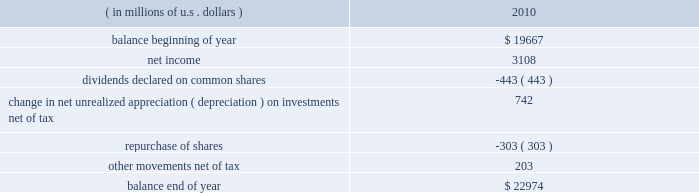The table reports the significant movements in our shareholders 2019 equity for the year ended december 31 , 2010. .
Total shareholders 2019 equity increased $ 3.3 billion in 2010 , primarily due to net income of $ 3.1 billion and the change in net unrealized appreciation on investments of $ 742 million .
Short-term debt at december 31 , 2010 , in connection with the financing of the rain and hail acquisition , short-term debt includes reverse repurchase agreements totaling $ 1 billion .
In addition , $ 300 million in borrowings against ace 2019s revolving credit facility were outstanding at december 31 , 2010 .
At december 31 , 2009 , short-term debt consisted of a five-year term loan which we repaid in december 2010 .
Long-term debt our total long-term debt increased by $ 200 million during the year to $ 3.4 billion and is described in detail in note 9 to the consolidated financial statements , under item 8 .
In november 2010 , ace ina issued $ 700 million of 2.6 percent senior notes due november 2015 .
These senior unsecured notes are guaranteed on a senior basis by the company and they rank equally with all of the company 2019s other senior obligations .
In april 2008 , as part of the financing of the combined insurance acquisition , ace ina entered into a $ 450 million float- ing interest rate syndicated term loan agreement due april 2013 .
Simultaneously , the company entered into a swap transaction that had the economic effect of fixing the interest rate for the term of the loan .
In december 2010 , ace repaid this loan and exited the swap .
In december 2008 , ace ina entered into a $ 66 million dual tranche floating interest rate term loan agreement .
The first tranche , a $ 50 million three-year term loan due december 2011 , had a floating interest rate .
Simultaneously , the company entered into a swap transaction that had the economic effect of fixing the interest rate for the term of the loan .
In december 2010 , ace repaid this loan and exited the swap .
The second tranche , a $ 16 million nine-month term loan , was due and repaid in september 2009 .
Trust preferred securities the securities outstanding consist of $ 300 million of trust preferred securities due 2030 , issued by a special purpose entity ( a trust ) that is wholly owned by us .
The sole assets of the special purpose entity are debt instruments issued by one or more of our subsidiaries .
The special purpose entity looks to payments on the debt instruments to make payments on the preferred securities .
We have guaranteed the payments on these debt instruments .
The trustees of the trust include one or more of our officers and at least one independent trustee , such as a trust company .
Our officers serving as trustees of the trust do not receive any compensation or other remuneration for their services in such capacity .
The full $ 309 million of outstanding trust preferred securities ( calculated as $ 300 million as discussed above plus our equity share of the trust ) is shown on our con- solidated balance sheet as a liability .
Additional information with respect to the trust preferred securities is contained in note 9 d ) to the consolidated financial statements , under item 8 .
Common shares our common shares had a par value of chf 30.57 each at december 31 , 2010 .
At the annual general meeting held in may 2010 , the company 2019s shareholders approved a par value reduction in an aggregate swiss franc amount , pursuant to a formula , equal to $ 1.32 per share , which we refer to as the base annual divi- dend .
The base annual dividend is payable in four installments , provided that each of the swiss franc installments will be .
What is the net change in shareholders 2019 equity in 2010 ( in millions ) ? 
Computations: (22974 - 19667)
Answer: 3307.0. The table reports the significant movements in our shareholders 2019 equity for the year ended december 31 , 2010. .
Total shareholders 2019 equity increased $ 3.3 billion in 2010 , primarily due to net income of $ 3.1 billion and the change in net unrealized appreciation on investments of $ 742 million .
Short-term debt at december 31 , 2010 , in connection with the financing of the rain and hail acquisition , short-term debt includes reverse repurchase agreements totaling $ 1 billion .
In addition , $ 300 million in borrowings against ace 2019s revolving credit facility were outstanding at december 31 , 2010 .
At december 31 , 2009 , short-term debt consisted of a five-year term loan which we repaid in december 2010 .
Long-term debt our total long-term debt increased by $ 200 million during the year to $ 3.4 billion and is described in detail in note 9 to the consolidated financial statements , under item 8 .
In november 2010 , ace ina issued $ 700 million of 2.6 percent senior notes due november 2015 .
These senior unsecured notes are guaranteed on a senior basis by the company and they rank equally with all of the company 2019s other senior obligations .
In april 2008 , as part of the financing of the combined insurance acquisition , ace ina entered into a $ 450 million float- ing interest rate syndicated term loan agreement due april 2013 .
Simultaneously , the company entered into a swap transaction that had the economic effect of fixing the interest rate for the term of the loan .
In december 2010 , ace repaid this loan and exited the swap .
In december 2008 , ace ina entered into a $ 66 million dual tranche floating interest rate term loan agreement .
The first tranche , a $ 50 million three-year term loan due december 2011 , had a floating interest rate .
Simultaneously , the company entered into a swap transaction that had the economic effect of fixing the interest rate for the term of the loan .
In december 2010 , ace repaid this loan and exited the swap .
The second tranche , a $ 16 million nine-month term loan , was due and repaid in september 2009 .
Trust preferred securities the securities outstanding consist of $ 300 million of trust preferred securities due 2030 , issued by a special purpose entity ( a trust ) that is wholly owned by us .
The sole assets of the special purpose entity are debt instruments issued by one or more of our subsidiaries .
The special purpose entity looks to payments on the debt instruments to make payments on the preferred securities .
We have guaranteed the payments on these debt instruments .
The trustees of the trust include one or more of our officers and at least one independent trustee , such as a trust company .
Our officers serving as trustees of the trust do not receive any compensation or other remuneration for their services in such capacity .
The full $ 309 million of outstanding trust preferred securities ( calculated as $ 300 million as discussed above plus our equity share of the trust ) is shown on our con- solidated balance sheet as a liability .
Additional information with respect to the trust preferred securities is contained in note 9 d ) to the consolidated financial statements , under item 8 .
Common shares our common shares had a par value of chf 30.57 each at december 31 , 2010 .
At the annual general meeting held in may 2010 , the company 2019s shareholders approved a par value reduction in an aggregate swiss franc amount , pursuant to a formula , equal to $ 1.32 per share , which we refer to as the base annual divi- dend .
The base annual dividend is payable in four installments , provided that each of the swiss franc installments will be .
In 2010 what was the percent of the increase in the total shareholders 2019 equity primarily due net income? 
Computations: (3.1 / 3.3)
Answer: 0.93939. The table reports the significant movements in our shareholders 2019 equity for the year ended december 31 , 2010. .
Total shareholders 2019 equity increased $ 3.3 billion in 2010 , primarily due to net income of $ 3.1 billion and the change in net unrealized appreciation on investments of $ 742 million .
Short-term debt at december 31 , 2010 , in connection with the financing of the rain and hail acquisition , short-term debt includes reverse repurchase agreements totaling $ 1 billion .
In addition , $ 300 million in borrowings against ace 2019s revolving credit facility were outstanding at december 31 , 2010 .
At december 31 , 2009 , short-term debt consisted of a five-year term loan which we repaid in december 2010 .
Long-term debt our total long-term debt increased by $ 200 million during the year to $ 3.4 billion and is described in detail in note 9 to the consolidated financial statements , under item 8 .
In november 2010 , ace ina issued $ 700 million of 2.6 percent senior notes due november 2015 .
These senior unsecured notes are guaranteed on a senior basis by the company and they rank equally with all of the company 2019s other senior obligations .
In april 2008 , as part of the financing of the combined insurance acquisition , ace ina entered into a $ 450 million float- ing interest rate syndicated term loan agreement due april 2013 .
Simultaneously , the company entered into a swap transaction that had the economic effect of fixing the interest rate for the term of the loan .
In december 2010 , ace repaid this loan and exited the swap .
In december 2008 , ace ina entered into a $ 66 million dual tranche floating interest rate term loan agreement .
The first tranche , a $ 50 million three-year term loan due december 2011 , had a floating interest rate .
Simultaneously , the company entered into a swap transaction that had the economic effect of fixing the interest rate for the term of the loan .
In december 2010 , ace repaid this loan and exited the swap .
The second tranche , a $ 16 million nine-month term loan , was due and repaid in september 2009 .
Trust preferred securities the securities outstanding consist of $ 300 million of trust preferred securities due 2030 , issued by a special purpose entity ( a trust ) that is wholly owned by us .
The sole assets of the special purpose entity are debt instruments issued by one or more of our subsidiaries .
The special purpose entity looks to payments on the debt instruments to make payments on the preferred securities .
We have guaranteed the payments on these debt instruments .
The trustees of the trust include one or more of our officers and at least one independent trustee , such as a trust company .
Our officers serving as trustees of the trust do not receive any compensation or other remuneration for their services in such capacity .
The full $ 309 million of outstanding trust preferred securities ( calculated as $ 300 million as discussed above plus our equity share of the trust ) is shown on our con- solidated balance sheet as a liability .
Additional information with respect to the trust preferred securities is contained in note 9 d ) to the consolidated financial statements , under item 8 .
Common shares our common shares had a par value of chf 30.57 each at december 31 , 2010 .
At the annual general meeting held in may 2010 , the company 2019s shareholders approved a par value reduction in an aggregate swiss franc amount , pursuant to a formula , equal to $ 1.32 per share , which we refer to as the base annual divi- dend .
The base annual dividend is payable in four installments , provided that each of the swiss franc installments will be .
What was the percent of the change in the shareholders 2019 equity in 2010? 
Computations: ((22974 - 19667) / 19667)
Answer: 0.16815. 